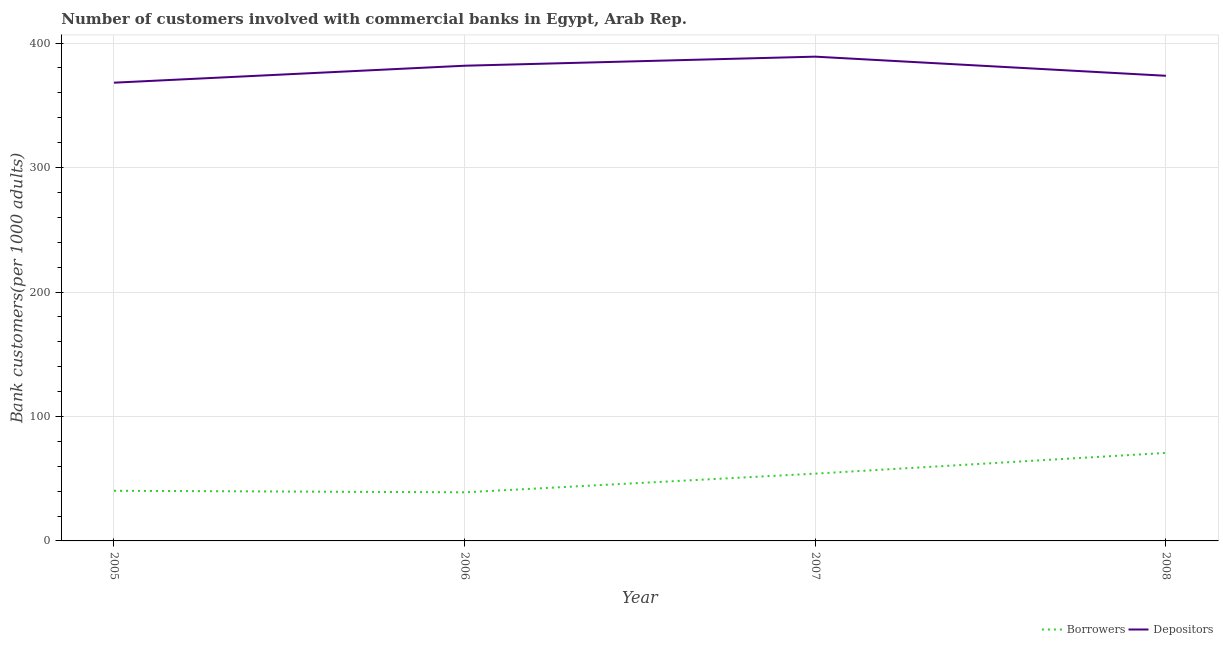How many different coloured lines are there?
Your response must be concise. 2. Does the line corresponding to number of depositors intersect with the line corresponding to number of borrowers?
Provide a succinct answer. No. What is the number of depositors in 2005?
Your answer should be compact. 368.19. Across all years, what is the maximum number of depositors?
Your response must be concise. 389.11. Across all years, what is the minimum number of depositors?
Your answer should be compact. 368.19. In which year was the number of borrowers minimum?
Your response must be concise. 2006. What is the total number of depositors in the graph?
Offer a very short reply. 1512.86. What is the difference between the number of borrowers in 2005 and that in 2008?
Provide a short and direct response. -30.45. What is the difference between the number of borrowers in 2006 and the number of depositors in 2007?
Keep it short and to the point. -350.06. What is the average number of depositors per year?
Give a very brief answer. 378.22. In the year 2008, what is the difference between the number of borrowers and number of depositors?
Your answer should be compact. -302.99. What is the ratio of the number of borrowers in 2007 to that in 2008?
Offer a very short reply. 0.76. Is the number of borrowers in 2005 less than that in 2006?
Your answer should be compact. No. Is the difference between the number of borrowers in 2005 and 2007 greater than the difference between the number of depositors in 2005 and 2007?
Offer a terse response. Yes. What is the difference between the highest and the second highest number of depositors?
Your answer should be compact. 7.28. What is the difference between the highest and the lowest number of depositors?
Your answer should be very brief. 20.91. In how many years, is the number of borrowers greater than the average number of borrowers taken over all years?
Give a very brief answer. 2. Does the number of depositors monotonically increase over the years?
Offer a terse response. No. Is the number of borrowers strictly greater than the number of depositors over the years?
Your response must be concise. No. How many lines are there?
Offer a terse response. 2. How many years are there in the graph?
Offer a very short reply. 4. What is the difference between two consecutive major ticks on the Y-axis?
Your response must be concise. 100. Are the values on the major ticks of Y-axis written in scientific E-notation?
Your response must be concise. No. Does the graph contain any zero values?
Keep it short and to the point. No. How many legend labels are there?
Keep it short and to the point. 2. What is the title of the graph?
Your answer should be very brief. Number of customers involved with commercial banks in Egypt, Arab Rep. What is the label or title of the Y-axis?
Provide a succinct answer. Bank customers(per 1000 adults). What is the Bank customers(per 1000 adults) in Borrowers in 2005?
Your answer should be very brief. 40.3. What is the Bank customers(per 1000 adults) of Depositors in 2005?
Provide a succinct answer. 368.19. What is the Bank customers(per 1000 adults) in Borrowers in 2006?
Your answer should be very brief. 39.05. What is the Bank customers(per 1000 adults) of Depositors in 2006?
Provide a succinct answer. 381.83. What is the Bank customers(per 1000 adults) of Borrowers in 2007?
Give a very brief answer. 54.06. What is the Bank customers(per 1000 adults) in Depositors in 2007?
Your answer should be very brief. 389.11. What is the Bank customers(per 1000 adults) in Borrowers in 2008?
Offer a terse response. 70.74. What is the Bank customers(per 1000 adults) in Depositors in 2008?
Your response must be concise. 373.74. Across all years, what is the maximum Bank customers(per 1000 adults) of Borrowers?
Keep it short and to the point. 70.74. Across all years, what is the maximum Bank customers(per 1000 adults) of Depositors?
Make the answer very short. 389.11. Across all years, what is the minimum Bank customers(per 1000 adults) of Borrowers?
Give a very brief answer. 39.05. Across all years, what is the minimum Bank customers(per 1000 adults) in Depositors?
Keep it short and to the point. 368.19. What is the total Bank customers(per 1000 adults) of Borrowers in the graph?
Your answer should be very brief. 204.15. What is the total Bank customers(per 1000 adults) in Depositors in the graph?
Provide a short and direct response. 1512.86. What is the difference between the Bank customers(per 1000 adults) of Borrowers in 2005 and that in 2006?
Your response must be concise. 1.25. What is the difference between the Bank customers(per 1000 adults) in Depositors in 2005 and that in 2006?
Give a very brief answer. -13.63. What is the difference between the Bank customers(per 1000 adults) in Borrowers in 2005 and that in 2007?
Make the answer very short. -13.77. What is the difference between the Bank customers(per 1000 adults) of Depositors in 2005 and that in 2007?
Provide a short and direct response. -20.91. What is the difference between the Bank customers(per 1000 adults) of Borrowers in 2005 and that in 2008?
Your answer should be very brief. -30.45. What is the difference between the Bank customers(per 1000 adults) in Depositors in 2005 and that in 2008?
Your answer should be compact. -5.54. What is the difference between the Bank customers(per 1000 adults) in Borrowers in 2006 and that in 2007?
Give a very brief answer. -15.02. What is the difference between the Bank customers(per 1000 adults) of Depositors in 2006 and that in 2007?
Offer a very short reply. -7.28. What is the difference between the Bank customers(per 1000 adults) of Borrowers in 2006 and that in 2008?
Make the answer very short. -31.69. What is the difference between the Bank customers(per 1000 adults) in Depositors in 2006 and that in 2008?
Provide a short and direct response. 8.09. What is the difference between the Bank customers(per 1000 adults) in Borrowers in 2007 and that in 2008?
Your response must be concise. -16.68. What is the difference between the Bank customers(per 1000 adults) in Depositors in 2007 and that in 2008?
Keep it short and to the point. 15.37. What is the difference between the Bank customers(per 1000 adults) of Borrowers in 2005 and the Bank customers(per 1000 adults) of Depositors in 2006?
Ensure brevity in your answer.  -341.53. What is the difference between the Bank customers(per 1000 adults) of Borrowers in 2005 and the Bank customers(per 1000 adults) of Depositors in 2007?
Your response must be concise. -348.81. What is the difference between the Bank customers(per 1000 adults) in Borrowers in 2005 and the Bank customers(per 1000 adults) in Depositors in 2008?
Ensure brevity in your answer.  -333.44. What is the difference between the Bank customers(per 1000 adults) in Borrowers in 2006 and the Bank customers(per 1000 adults) in Depositors in 2007?
Ensure brevity in your answer.  -350.06. What is the difference between the Bank customers(per 1000 adults) of Borrowers in 2006 and the Bank customers(per 1000 adults) of Depositors in 2008?
Your answer should be compact. -334.69. What is the difference between the Bank customers(per 1000 adults) in Borrowers in 2007 and the Bank customers(per 1000 adults) in Depositors in 2008?
Provide a short and direct response. -319.67. What is the average Bank customers(per 1000 adults) of Borrowers per year?
Provide a short and direct response. 51.04. What is the average Bank customers(per 1000 adults) of Depositors per year?
Make the answer very short. 378.22. In the year 2005, what is the difference between the Bank customers(per 1000 adults) of Borrowers and Bank customers(per 1000 adults) of Depositors?
Provide a short and direct response. -327.9. In the year 2006, what is the difference between the Bank customers(per 1000 adults) in Borrowers and Bank customers(per 1000 adults) in Depositors?
Offer a very short reply. -342.78. In the year 2007, what is the difference between the Bank customers(per 1000 adults) of Borrowers and Bank customers(per 1000 adults) of Depositors?
Offer a terse response. -335.04. In the year 2008, what is the difference between the Bank customers(per 1000 adults) in Borrowers and Bank customers(per 1000 adults) in Depositors?
Offer a very short reply. -302.99. What is the ratio of the Bank customers(per 1000 adults) in Borrowers in 2005 to that in 2006?
Offer a terse response. 1.03. What is the ratio of the Bank customers(per 1000 adults) in Depositors in 2005 to that in 2006?
Make the answer very short. 0.96. What is the ratio of the Bank customers(per 1000 adults) in Borrowers in 2005 to that in 2007?
Your answer should be very brief. 0.75. What is the ratio of the Bank customers(per 1000 adults) of Depositors in 2005 to that in 2007?
Ensure brevity in your answer.  0.95. What is the ratio of the Bank customers(per 1000 adults) of Borrowers in 2005 to that in 2008?
Your answer should be compact. 0.57. What is the ratio of the Bank customers(per 1000 adults) of Depositors in 2005 to that in 2008?
Ensure brevity in your answer.  0.99. What is the ratio of the Bank customers(per 1000 adults) of Borrowers in 2006 to that in 2007?
Provide a succinct answer. 0.72. What is the ratio of the Bank customers(per 1000 adults) in Depositors in 2006 to that in 2007?
Your answer should be very brief. 0.98. What is the ratio of the Bank customers(per 1000 adults) in Borrowers in 2006 to that in 2008?
Give a very brief answer. 0.55. What is the ratio of the Bank customers(per 1000 adults) of Depositors in 2006 to that in 2008?
Keep it short and to the point. 1.02. What is the ratio of the Bank customers(per 1000 adults) of Borrowers in 2007 to that in 2008?
Give a very brief answer. 0.76. What is the ratio of the Bank customers(per 1000 adults) of Depositors in 2007 to that in 2008?
Provide a short and direct response. 1.04. What is the difference between the highest and the second highest Bank customers(per 1000 adults) of Borrowers?
Your response must be concise. 16.68. What is the difference between the highest and the second highest Bank customers(per 1000 adults) of Depositors?
Give a very brief answer. 7.28. What is the difference between the highest and the lowest Bank customers(per 1000 adults) in Borrowers?
Offer a very short reply. 31.69. What is the difference between the highest and the lowest Bank customers(per 1000 adults) of Depositors?
Give a very brief answer. 20.91. 